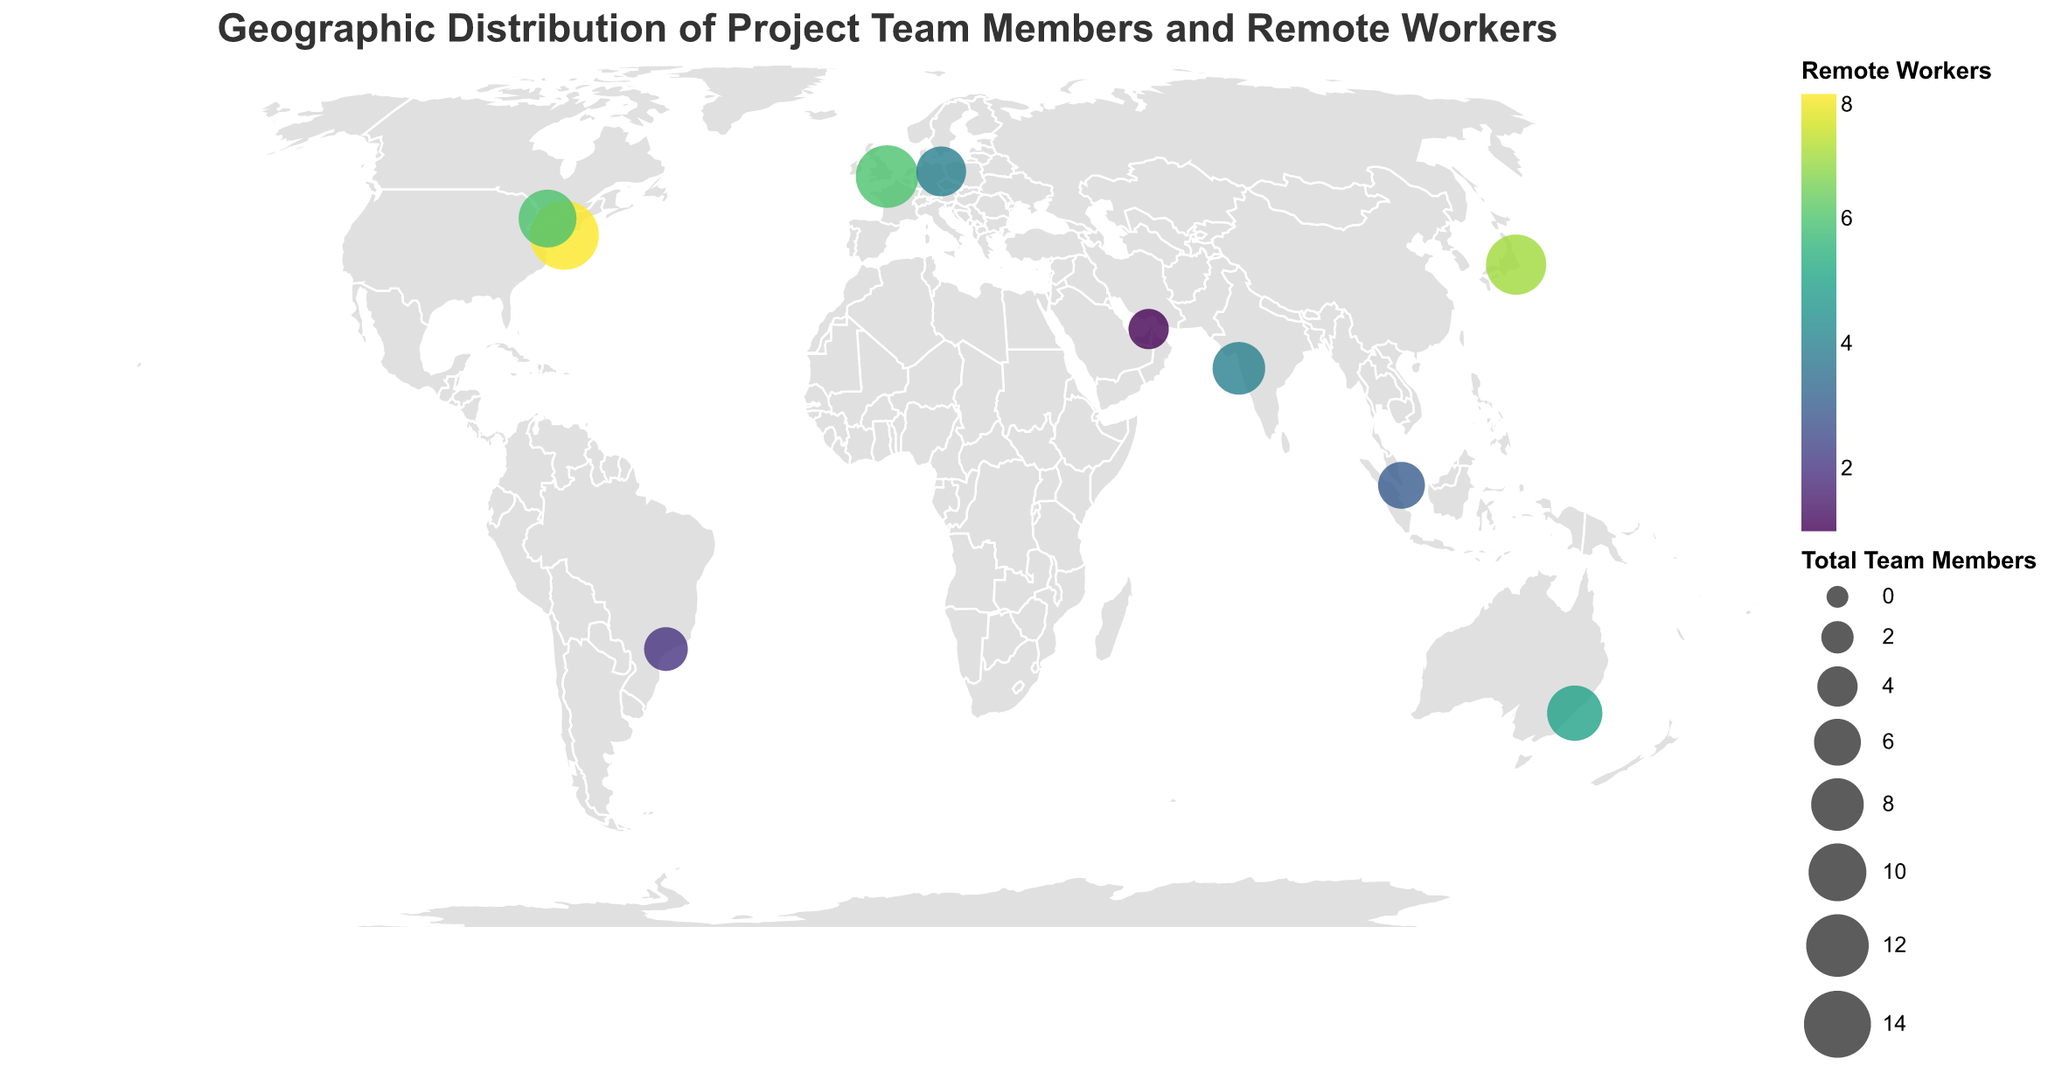Which city has the highest number of team members? Looking at the geographic plot, the size of the circle for New York is the largest, and the tooltip indicates it has 15 team members.
Answer: New York What is the total number of remote workers in London and Toronto? According to the geographic plot, London has 6 remote workers and Toronto has 6 remote workers. Adding them together, 6 (London) + 6 (Toronto) equals 12.
Answer: 12 Which city has fewer remote workers, São Paulo or Berlin? The tooltip on the geographic plot shows that São Paulo has 2 remote workers, while Berlin has 4 remote workers. Comparing these values, São Paulo has fewer remote workers.
Answer: São Paulo Are there more team members in Sydney than in Tokyo? According to the tooltip, Sydney has 9 team members and Tokyo has 11 team members. Therefore, Tokyo has more team members than Sydney.
Answer: No What is the average number of team members across all cities? Summing up the number of team members in all cities: 15 (New York) + 12 (London) + 8 (Mumbai) + 6 (Singapore) + 9 (Sydney) + 7 (Berlin) + 10 (Toronto) + 5 (São Paulo) + 4 (Dubai) + 11 (Tokyo) gives a total of 87. There are 10 cities, so the average is 87 / 10 = 8.7.
Answer: 8.7 What is the total number of team members in countries outside of Asia and North America? From the geographic plot, the relevant cities are London (12), Sydney (9), Berlin (7), São Paulo (5), and Dubai (4) – which sum to 12 + 9 + 7 + 5 + 4 = 37.
Answer: 37 